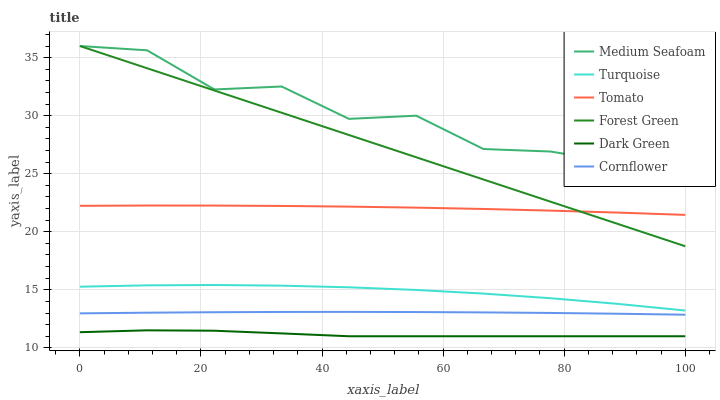Does Dark Green have the minimum area under the curve?
Answer yes or no. Yes. Does Medium Seafoam have the maximum area under the curve?
Answer yes or no. Yes. Does Cornflower have the minimum area under the curve?
Answer yes or no. No. Does Cornflower have the maximum area under the curve?
Answer yes or no. No. Is Forest Green the smoothest?
Answer yes or no. Yes. Is Medium Seafoam the roughest?
Answer yes or no. Yes. Is Cornflower the smoothest?
Answer yes or no. No. Is Cornflower the roughest?
Answer yes or no. No. Does Dark Green have the lowest value?
Answer yes or no. Yes. Does Cornflower have the lowest value?
Answer yes or no. No. Does Medium Seafoam have the highest value?
Answer yes or no. Yes. Does Cornflower have the highest value?
Answer yes or no. No. Is Turquoise less than Tomato?
Answer yes or no. Yes. Is Forest Green greater than Turquoise?
Answer yes or no. Yes. Does Forest Green intersect Tomato?
Answer yes or no. Yes. Is Forest Green less than Tomato?
Answer yes or no. No. Is Forest Green greater than Tomato?
Answer yes or no. No. Does Turquoise intersect Tomato?
Answer yes or no. No. 